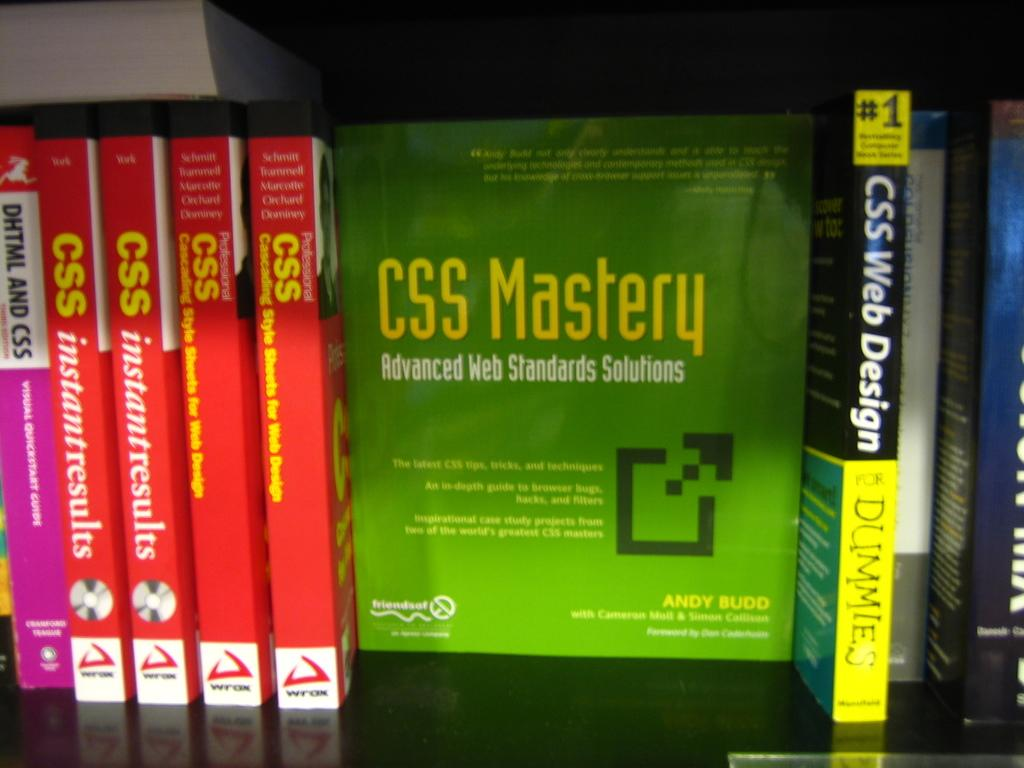<image>
Offer a succinct explanation of the picture presented. A collection of CSS books for web and computer information. 